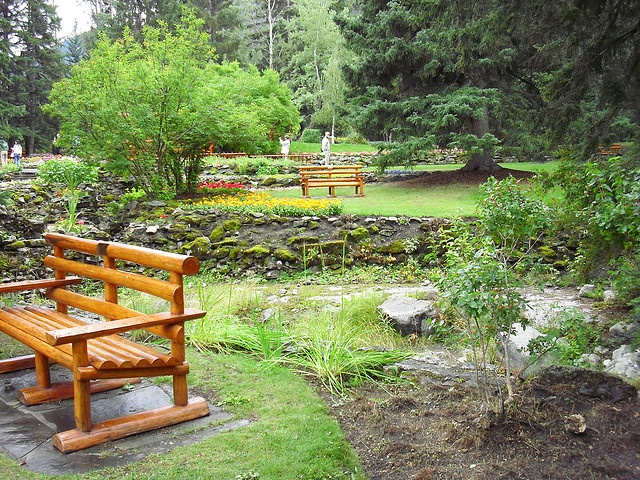Describe the objects in this image and their specific colors. I can see bench in gray, brown, maroon, orange, and lightgray tones, bench in gray, beige, khaki, brown, and orange tones, bench in gray, olive, black, and maroon tones, people in gray, white, darkgray, and beige tones, and people in gray, white, and darkgray tones in this image. 